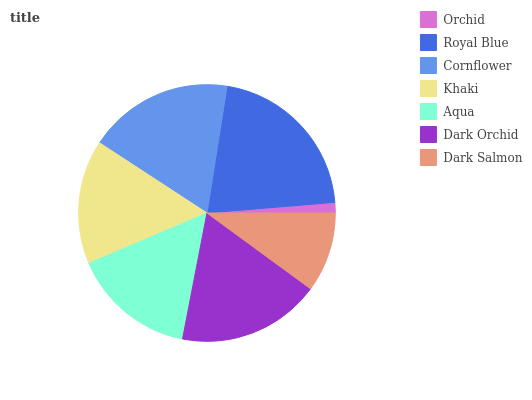Is Orchid the minimum?
Answer yes or no. Yes. Is Royal Blue the maximum?
Answer yes or no. Yes. Is Cornflower the minimum?
Answer yes or no. No. Is Cornflower the maximum?
Answer yes or no. No. Is Royal Blue greater than Cornflower?
Answer yes or no. Yes. Is Cornflower less than Royal Blue?
Answer yes or no. Yes. Is Cornflower greater than Royal Blue?
Answer yes or no. No. Is Royal Blue less than Cornflower?
Answer yes or no. No. Is Khaki the high median?
Answer yes or no. Yes. Is Khaki the low median?
Answer yes or no. Yes. Is Dark Orchid the high median?
Answer yes or no. No. Is Dark Orchid the low median?
Answer yes or no. No. 